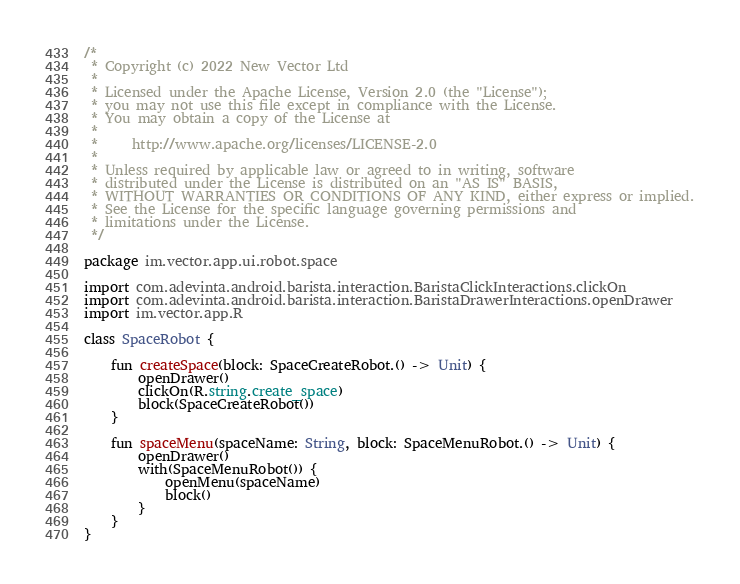<code> <loc_0><loc_0><loc_500><loc_500><_Kotlin_>/*
 * Copyright (c) 2022 New Vector Ltd
 *
 * Licensed under the Apache License, Version 2.0 (the "License");
 * you may not use this file except in compliance with the License.
 * You may obtain a copy of the License at
 *
 *     http://www.apache.org/licenses/LICENSE-2.0
 *
 * Unless required by applicable law or agreed to in writing, software
 * distributed under the License is distributed on an "AS IS" BASIS,
 * WITHOUT WARRANTIES OR CONDITIONS OF ANY KIND, either express or implied.
 * See the License for the specific language governing permissions and
 * limitations under the License.
 */

package im.vector.app.ui.robot.space

import com.adevinta.android.barista.interaction.BaristaClickInteractions.clickOn
import com.adevinta.android.barista.interaction.BaristaDrawerInteractions.openDrawer
import im.vector.app.R

class SpaceRobot {

    fun createSpace(block: SpaceCreateRobot.() -> Unit) {
        openDrawer()
        clickOn(R.string.create_space)
        block(SpaceCreateRobot())
    }

    fun spaceMenu(spaceName: String, block: SpaceMenuRobot.() -> Unit) {
        openDrawer()
        with(SpaceMenuRobot()) {
            openMenu(spaceName)
            block()
        }
    }
}
</code> 